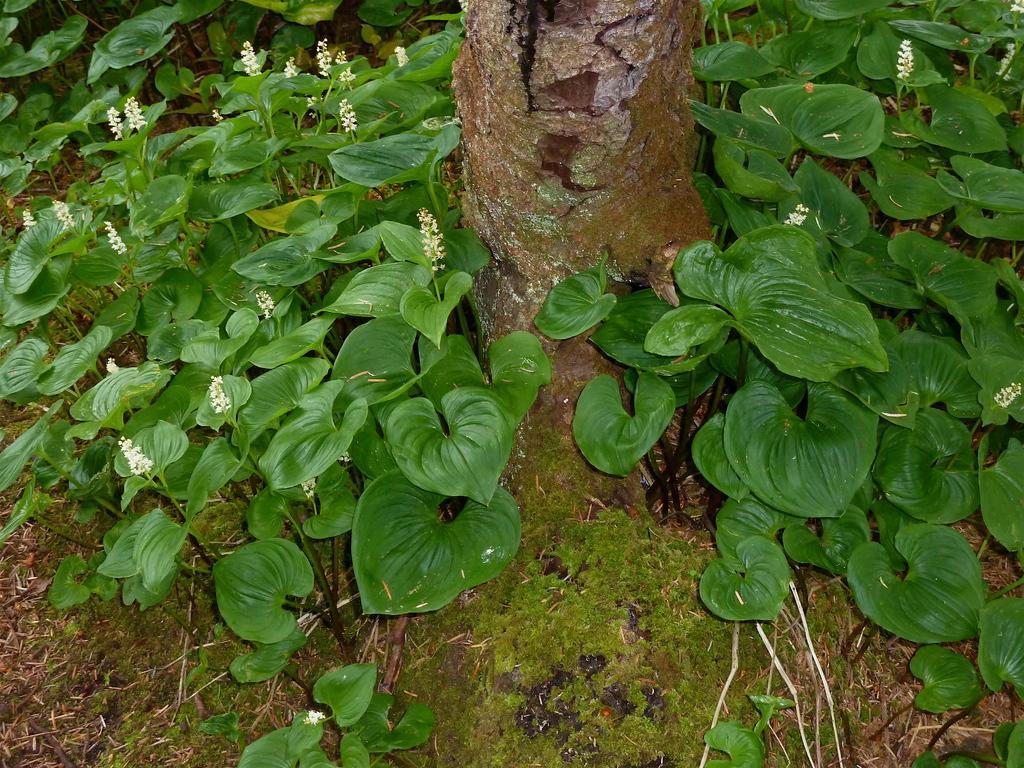Describe this image in one or two sentences. In this image we can see plants with small flowers and grass on the ground and there is a tree trunk. 